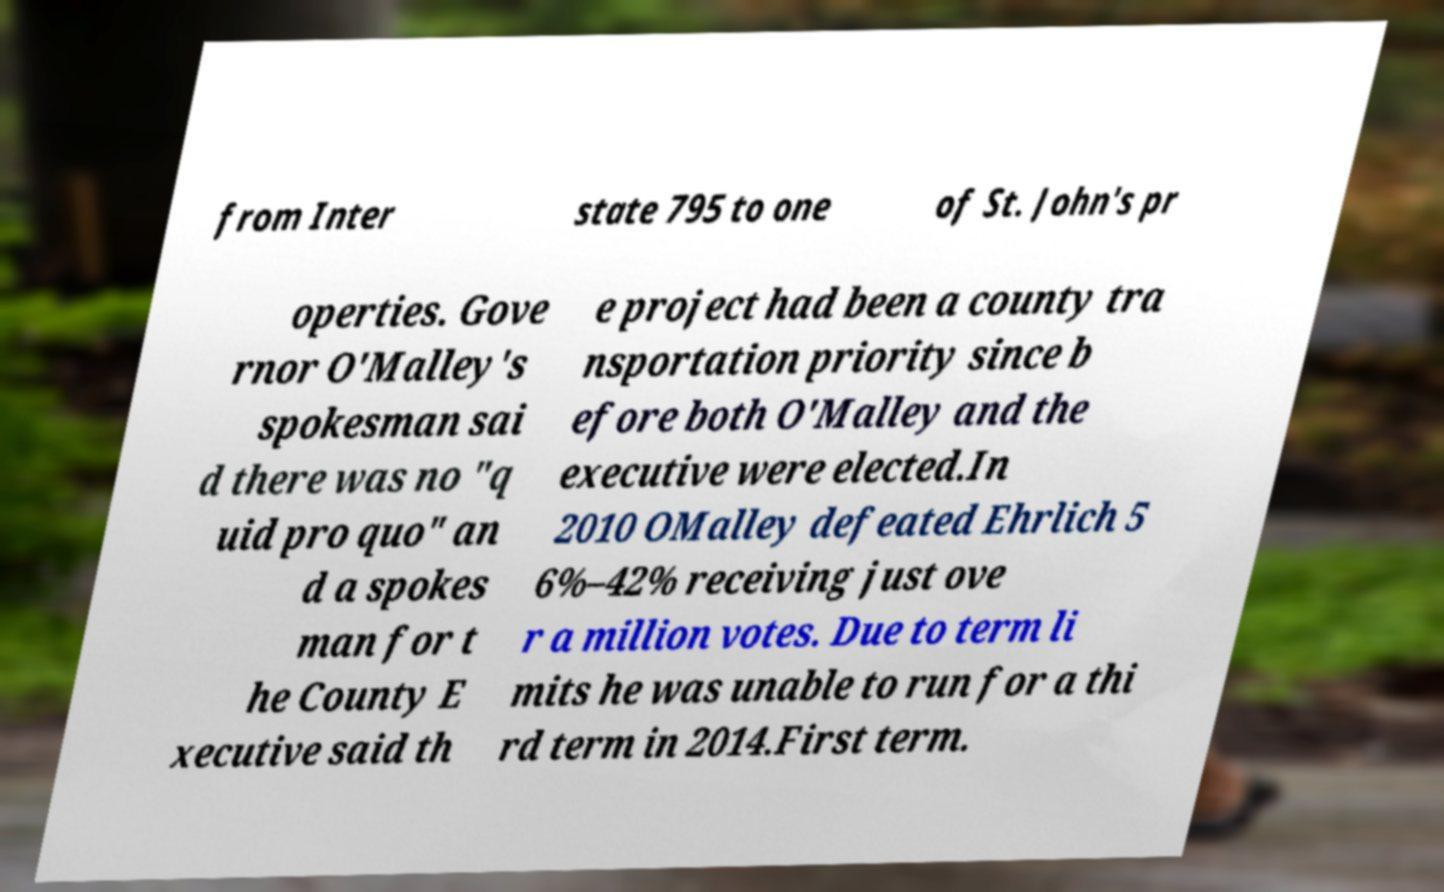I need the written content from this picture converted into text. Can you do that? from Inter state 795 to one of St. John's pr operties. Gove rnor O'Malley's spokesman sai d there was no "q uid pro quo" an d a spokes man for t he County E xecutive said th e project had been a county tra nsportation priority since b efore both O'Malley and the executive were elected.In 2010 OMalley defeated Ehrlich 5 6%–42% receiving just ove r a million votes. Due to term li mits he was unable to run for a thi rd term in 2014.First term. 